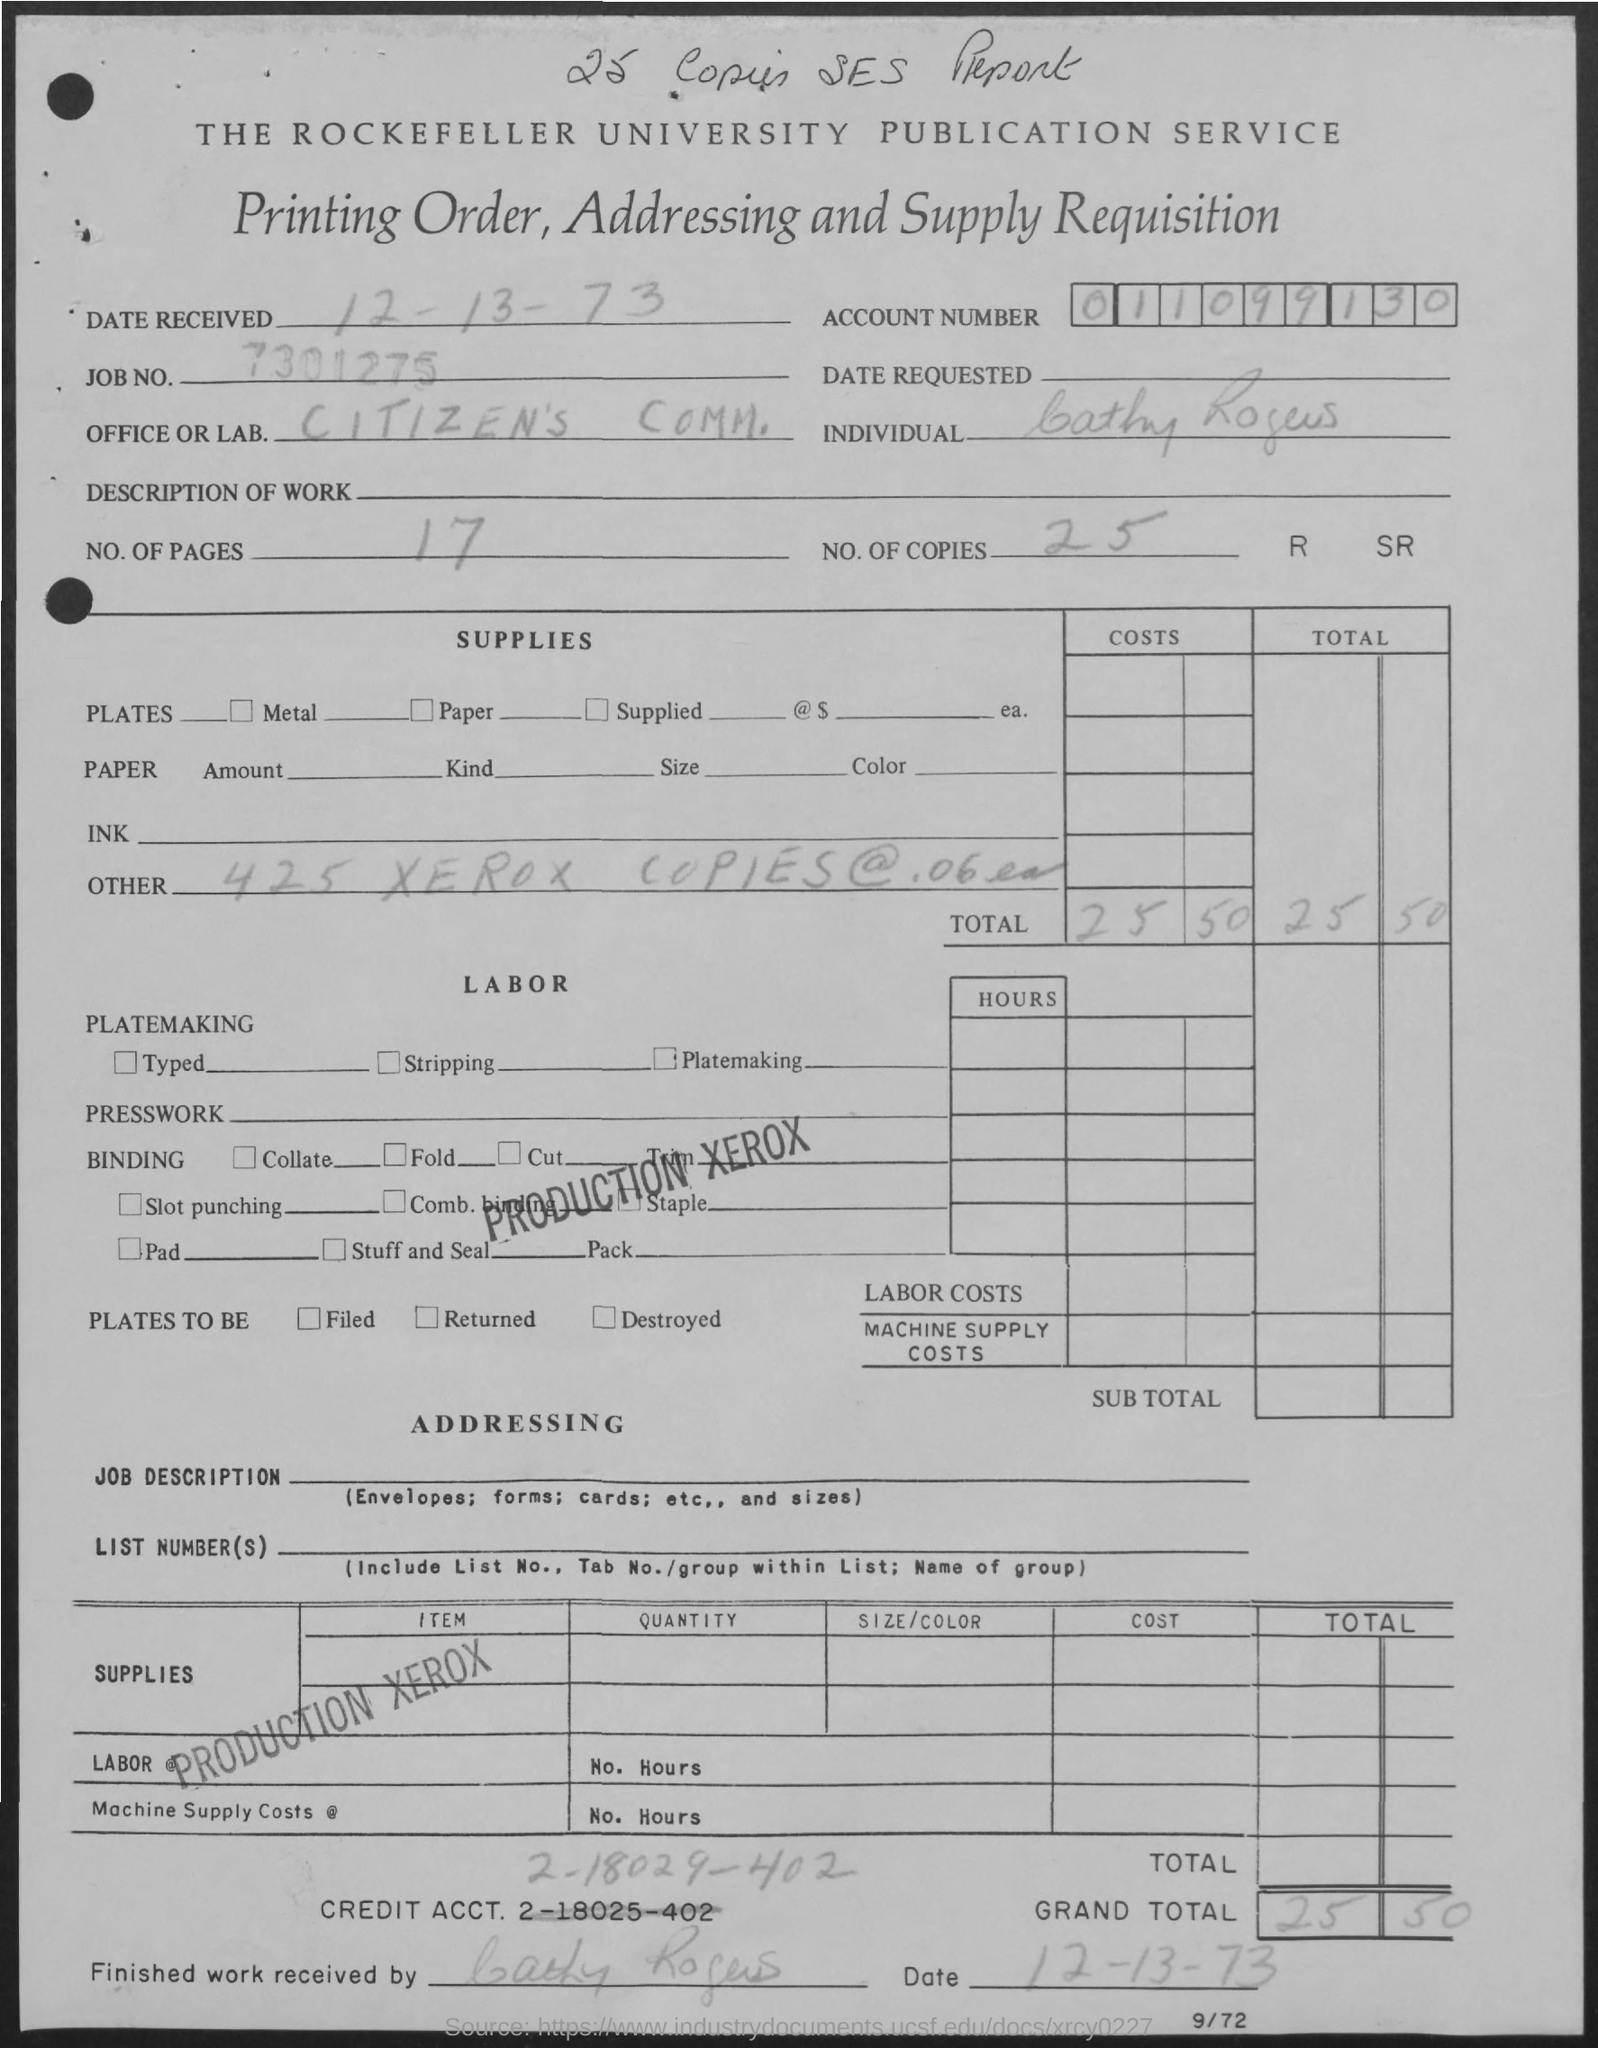How many copies are mentioned? The document mentions a total of 25 copies under the 'NO. OF COPIES' section. 